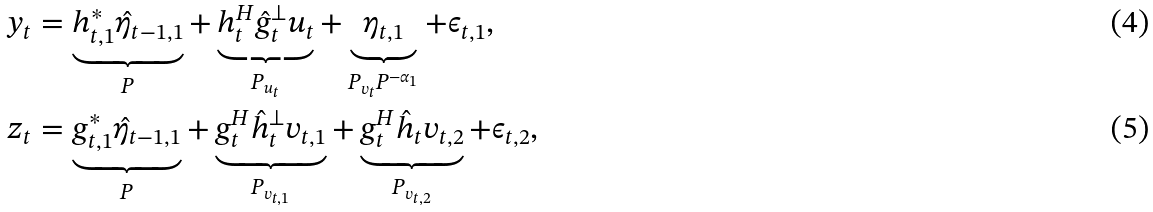<formula> <loc_0><loc_0><loc_500><loc_500>y _ { t } & = \underbrace { h _ { t , 1 } ^ { * } \hat { \eta } _ { t - 1 , 1 } } _ { P } + \underbrace { h _ { t } ^ { H } \hat { g } _ { t } ^ { \bot } u _ { t } } _ { P _ { u _ { t } } } + \underbrace { \eta _ { t , 1 } } _ { P _ { v _ { t } } P ^ { - \alpha _ { 1 } } } + \epsilon _ { t , 1 } , \\ z _ { t } & = \underbrace { g _ { t , 1 } ^ { * } \hat { \eta } _ { t - 1 , 1 } } _ { P } + \underbrace { g _ { t } ^ { H } \hat { h } _ { t } ^ { \bot } v _ { t , 1 } } _ { P _ { v _ { t , 1 } } } + \underbrace { g _ { t } ^ { H } \hat { h } _ { t } v _ { t , 2 } } _ { P _ { v _ { t , 2 } } } + \epsilon _ { t , 2 } ,</formula> 